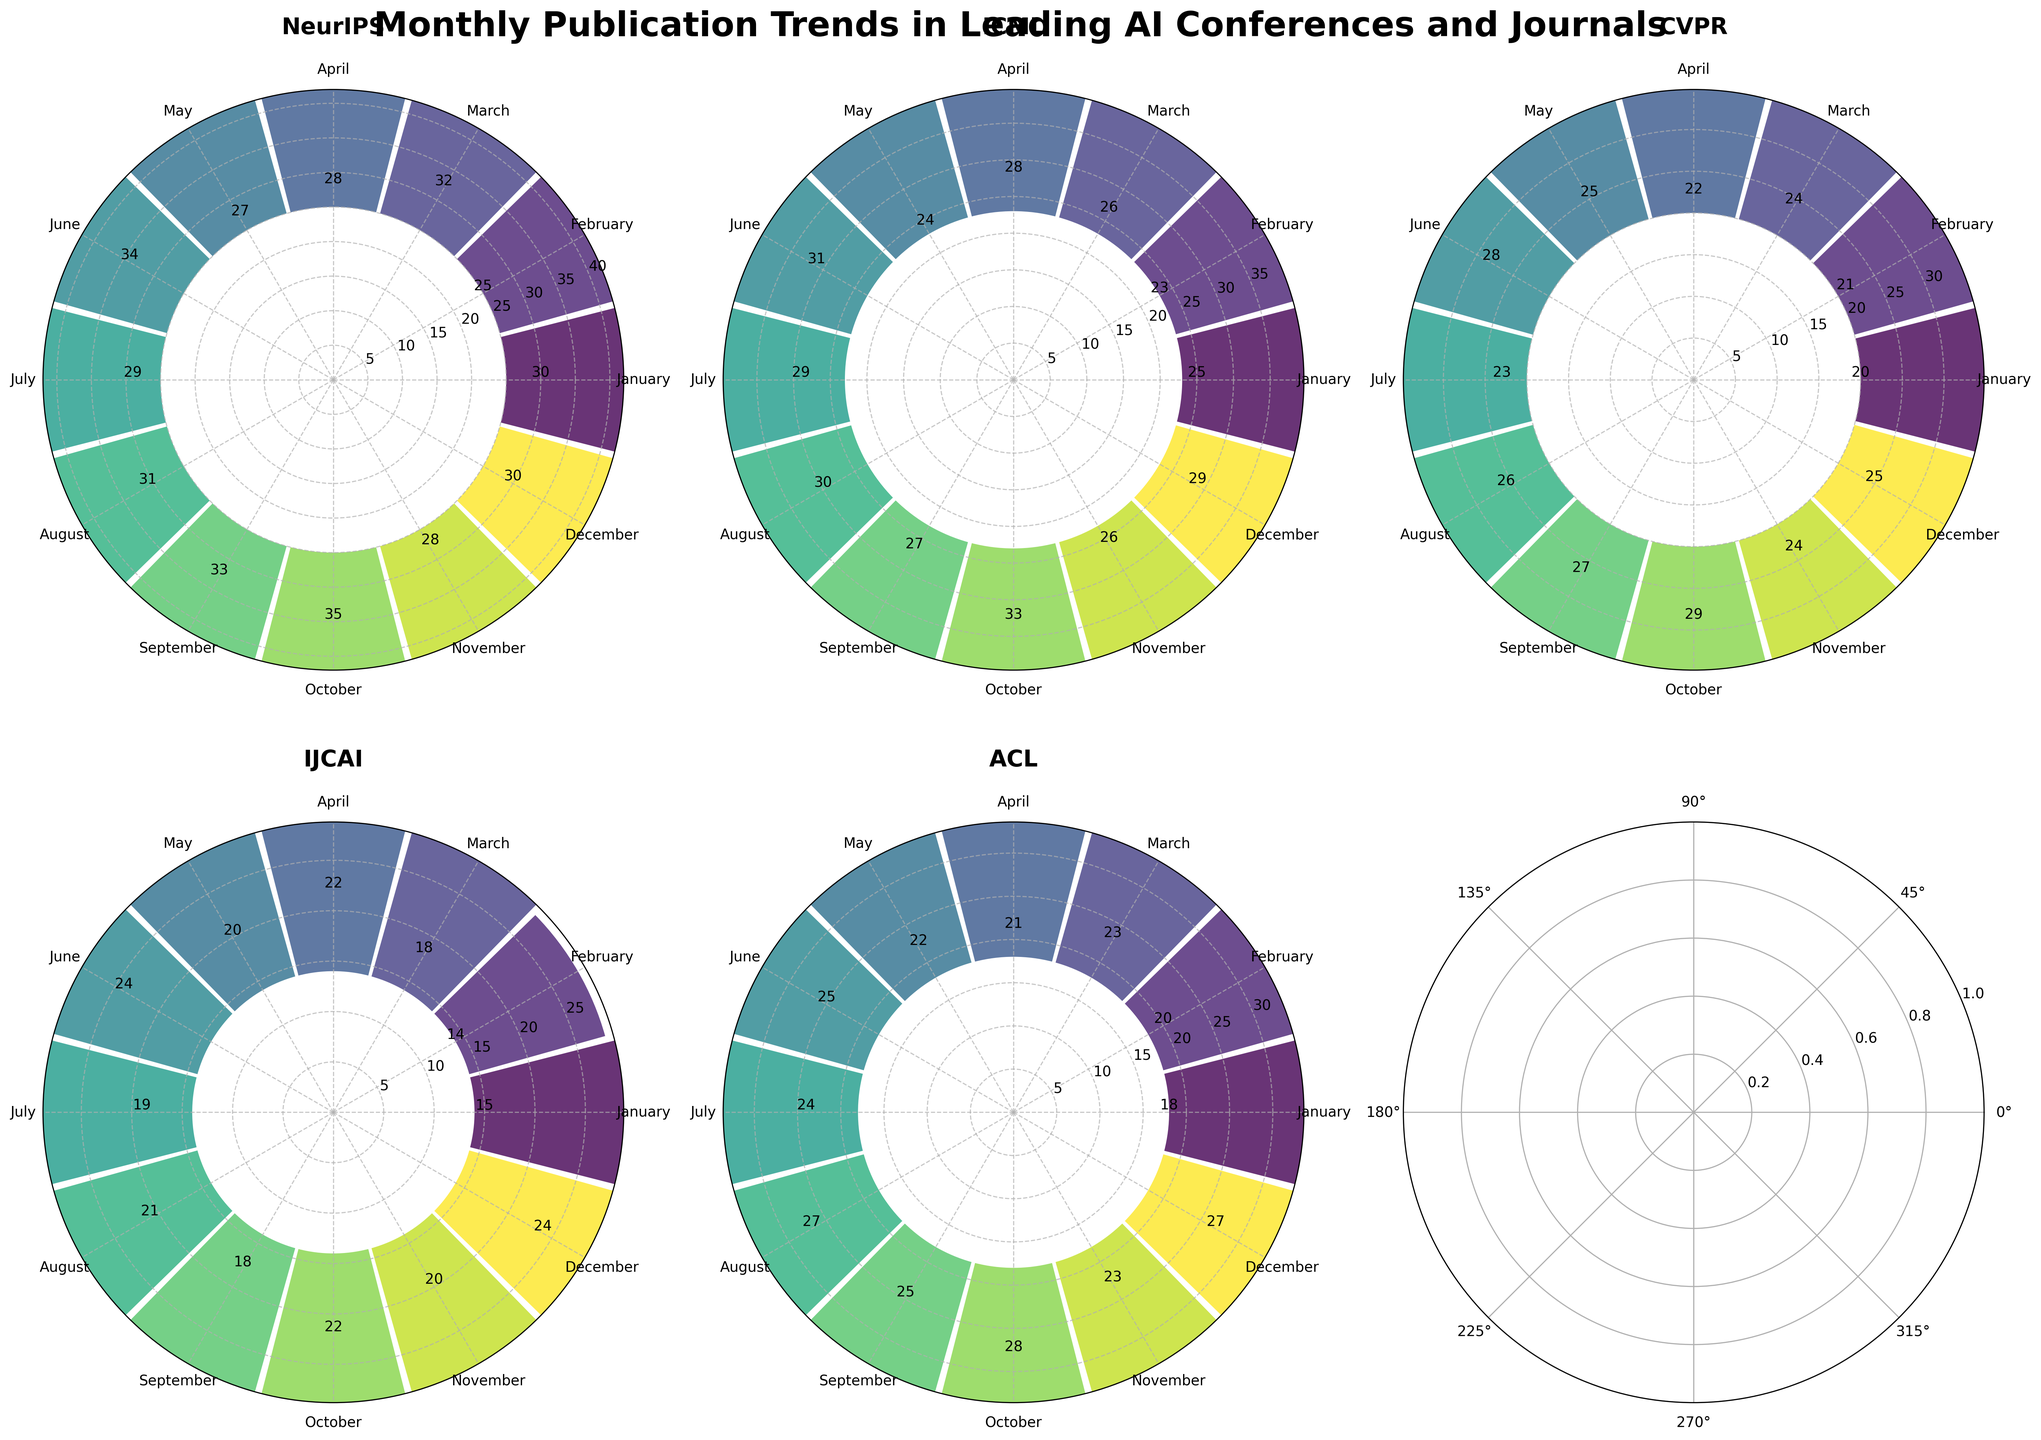What's the title of the figure? The title of the figure is displayed prominently at the top of the plot. It helps viewers understand what the figure represents.
Answer: "Monthly Publication Trends in Leading AI Conferences and Journals" How many subplots are there in the figure? By looking at the overall figure, you can see the individual subplots divided into sections. Each subplot represents a different conference or journal.
Answer: 6 Which conference or journal has consistently the lowest number of publications throughout the year? By comparing the heights of the bars in each subplot, identify the conference or journal with the shortest bars.
Answer: IJCAI Which month has the highest number of publications for NeurIPS? Look at the subplot for NeurIPS and identify the month with the longest bar.
Answer: October What is the range of the number of publications for CVPR across all months? Identify the minimum and maximum values from the CVPR subplot and subtract the minimum from the maximum.
Answer: 29 - 20 = 9 Which month has the highest total number of publications across all conferences and journals? Sum the number of publications for each month across all subplots, then identify the month with the highest total.
Answer: October For ACL, what is the difference in the number of publications between June and December? Compare the bar heights of June and December in the ACL subplot and subtract the lower value from the higher one to determine the difference.
Answer: 27 - 25 = 2 In which months does IJCAI have more publications than ACL? Compare the bar heights of IJCAI and ACL subplots for each month, then list the months where IJCAI's bars are taller.
Answer: April, May, November, December What is the average number of publications for ICML in the first six months of the year? Sum the number of publications for ICML from January to June and divide by 6 to get the average.
Answer: (25+23+26+28+24+31) / 6 = 25.5 Which conference or journal shows the greatest variation in the number of publications across months? Determine the difference between the highest and lowest number of publications for each conference or journal and identify the one with the greatest difference.
Answer: NeurIPS (35 - 25 = 10) 